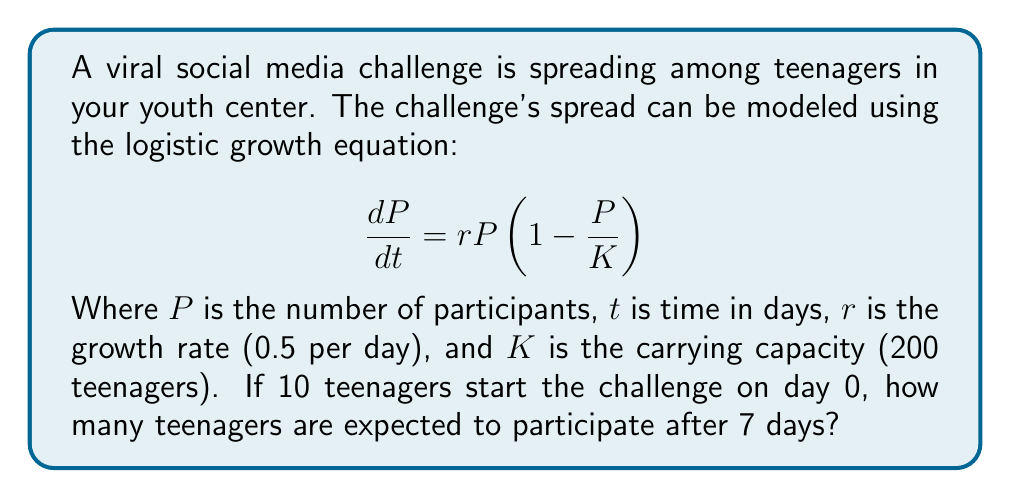Can you solve this math problem? To solve this problem, we need to use the solution to the logistic growth equation:

$$P(t) = \frac{KP_0}{P_0 + (K-P_0)e^{-rt}}$$

Where:
$P(t)$ is the number of participants at time $t$
$K = 200$ (carrying capacity)
$P_0 = 10$ (initial number of participants)
$r = 0.5$ (growth rate per day)
$t = 7$ (days)

Let's substitute these values into the equation:

$$P(7) = \frac{200 \cdot 10}{10 + (200-10)e^{-0.5 \cdot 7}}$$

$$P(7) = \frac{2000}{10 + 190e^{-3.5}}$$

Now, let's calculate this step by step:

1. Calculate $e^{-3.5}$:
   $e^{-3.5} \approx 0.0302$

2. Multiply by 190:
   $190 \cdot 0.0302 \approx 5.738$

3. Add 10:
   $10 + 5.738 = 15.738$

4. Divide 2000 by this result:
   $\frac{2000}{15.738} \approx 127.08$

5. Round to the nearest whole number (since we can't have partial participants):
   $127$

Therefore, after 7 days, approximately 127 teenagers are expected to participate in the challenge.
Answer: 127 teenagers 